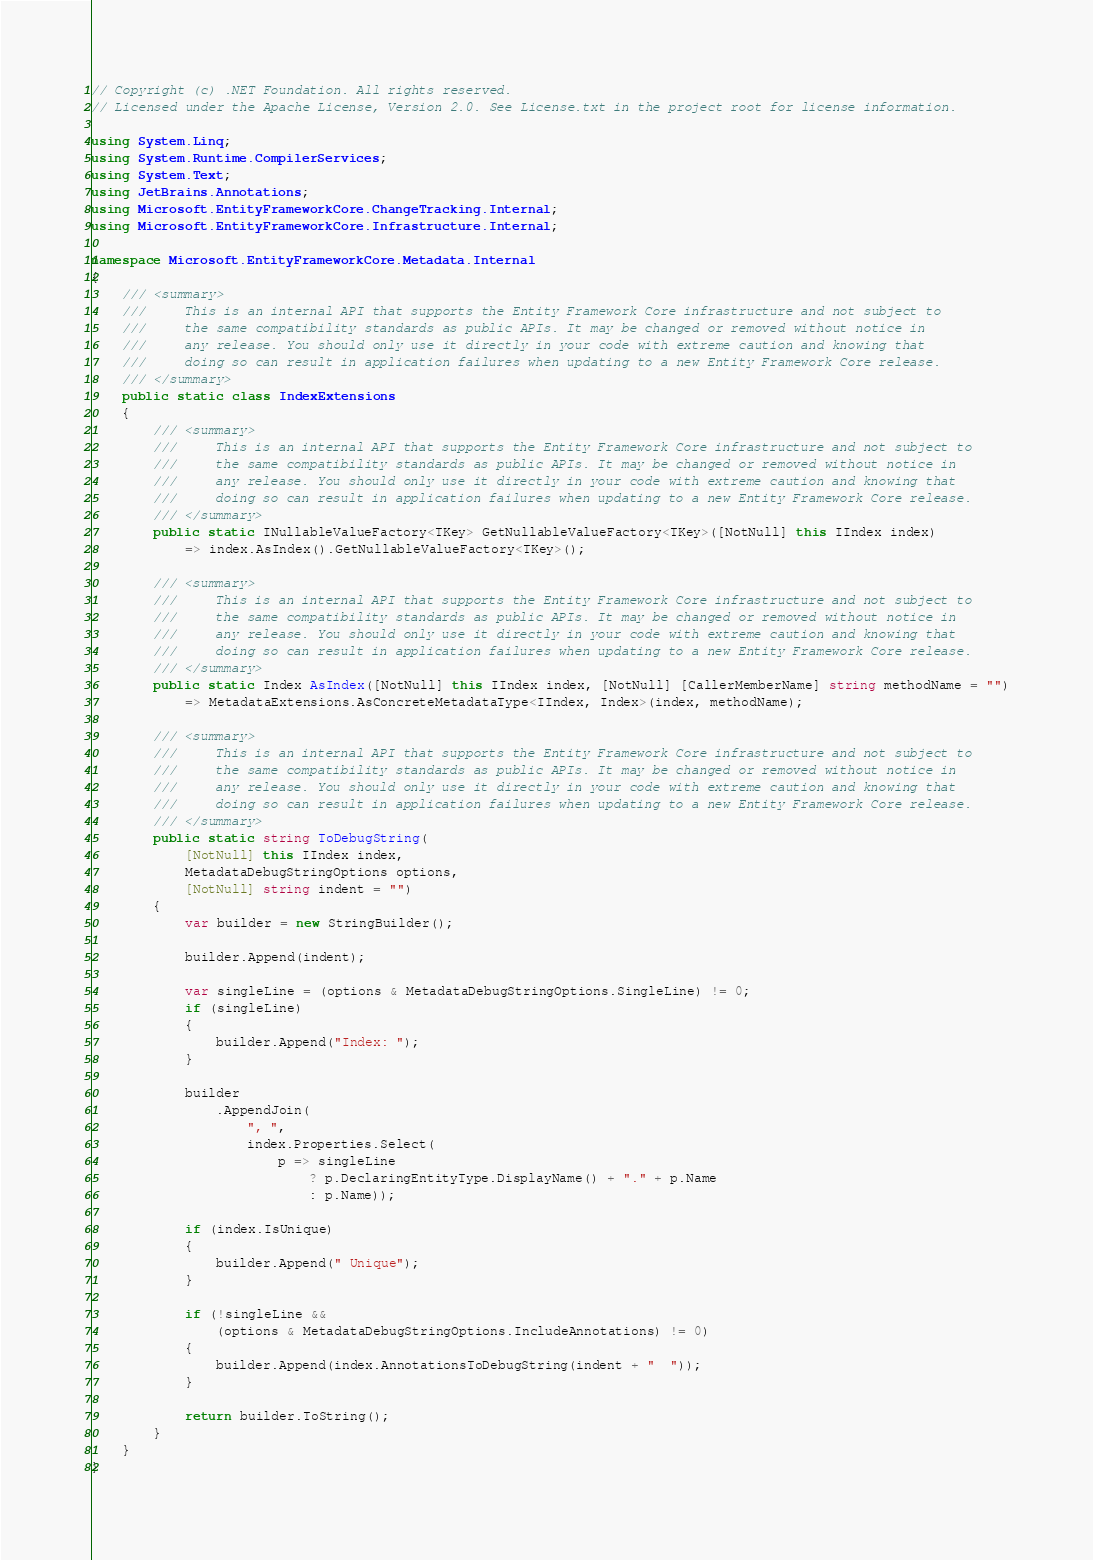Convert code to text. <code><loc_0><loc_0><loc_500><loc_500><_C#_>// Copyright (c) .NET Foundation. All rights reserved.
// Licensed under the Apache License, Version 2.0. See License.txt in the project root for license information.

using System.Linq;
using System.Runtime.CompilerServices;
using System.Text;
using JetBrains.Annotations;
using Microsoft.EntityFrameworkCore.ChangeTracking.Internal;
using Microsoft.EntityFrameworkCore.Infrastructure.Internal;

namespace Microsoft.EntityFrameworkCore.Metadata.Internal
{
    /// <summary>
    ///     This is an internal API that supports the Entity Framework Core infrastructure and not subject to
    ///     the same compatibility standards as public APIs. It may be changed or removed without notice in
    ///     any release. You should only use it directly in your code with extreme caution and knowing that
    ///     doing so can result in application failures when updating to a new Entity Framework Core release.
    /// </summary>
    public static class IndexExtensions
    {
        /// <summary>
        ///     This is an internal API that supports the Entity Framework Core infrastructure and not subject to
        ///     the same compatibility standards as public APIs. It may be changed or removed without notice in
        ///     any release. You should only use it directly in your code with extreme caution and knowing that
        ///     doing so can result in application failures when updating to a new Entity Framework Core release.
        /// </summary>
        public static INullableValueFactory<TKey> GetNullableValueFactory<TKey>([NotNull] this IIndex index)
            => index.AsIndex().GetNullableValueFactory<TKey>();

        /// <summary>
        ///     This is an internal API that supports the Entity Framework Core infrastructure and not subject to
        ///     the same compatibility standards as public APIs. It may be changed or removed without notice in
        ///     any release. You should only use it directly in your code with extreme caution and knowing that
        ///     doing so can result in application failures when updating to a new Entity Framework Core release.
        /// </summary>
        public static Index AsIndex([NotNull] this IIndex index, [NotNull] [CallerMemberName] string methodName = "")
            => MetadataExtensions.AsConcreteMetadataType<IIndex, Index>(index, methodName);

        /// <summary>
        ///     This is an internal API that supports the Entity Framework Core infrastructure and not subject to
        ///     the same compatibility standards as public APIs. It may be changed or removed without notice in
        ///     any release. You should only use it directly in your code with extreme caution and knowing that
        ///     doing so can result in application failures when updating to a new Entity Framework Core release.
        /// </summary>
        public static string ToDebugString(
            [NotNull] this IIndex index,
            MetadataDebugStringOptions options,
            [NotNull] string indent = "")
        {
            var builder = new StringBuilder();

            builder.Append(indent);

            var singleLine = (options & MetadataDebugStringOptions.SingleLine) != 0;
            if (singleLine)
            {
                builder.Append("Index: ");
            }

            builder
                .AppendJoin(
                    ", ",
                    index.Properties.Select(
                        p => singleLine
                            ? p.DeclaringEntityType.DisplayName() + "." + p.Name
                            : p.Name));

            if (index.IsUnique)
            {
                builder.Append(" Unique");
            }

            if (!singleLine &&
                (options & MetadataDebugStringOptions.IncludeAnnotations) != 0)
            {
                builder.Append(index.AnnotationsToDebugString(indent + "  "));
            }

            return builder.ToString();
        }
    }
}
</code> 